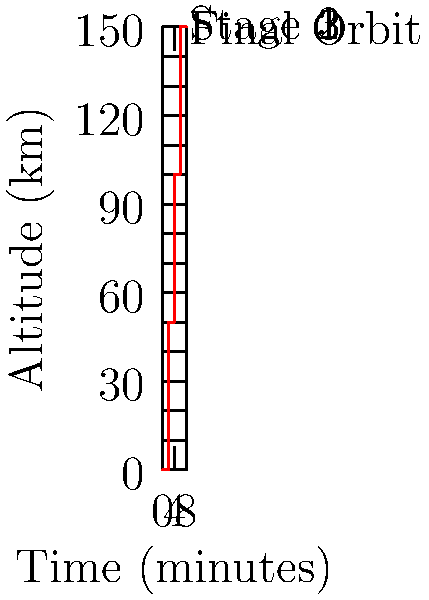The graph shows the altitude of a three-stage rocket launch over time. What is the total change in altitude (in km) from the beginning of Stage 2 to the end of Stage 3? To solve this problem, let's follow these steps:

1. Identify the altitude at the beginning of Stage 2:
   From the graph, we can see that Stage 2 begins at 2 minutes, where the altitude is 50 km.

2. Identify the altitude at the end of Stage 3:
   Stage 3 ends at 6 minutes, where the altitude is 150 km.

3. Calculate the change in altitude:
   Change in altitude = Final altitude - Initial altitude
   $\Delta h = h_{final} - h_{initial}$
   $\Delta h = 150 \text{ km} - 50 \text{ km} = 100 \text{ km}$

Therefore, the total change in altitude from the beginning of Stage 2 to the end of Stage 3 is 100 km.
Answer: 100 km 